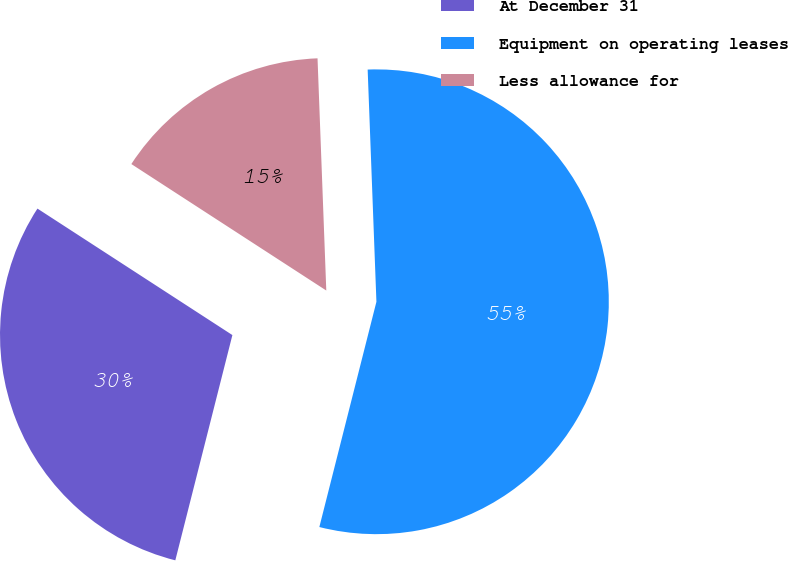Convert chart. <chart><loc_0><loc_0><loc_500><loc_500><pie_chart><fcel>At December 31<fcel>Equipment on operating leases<fcel>Less allowance for<nl><fcel>30.21%<fcel>54.55%<fcel>15.24%<nl></chart> 